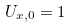<formula> <loc_0><loc_0><loc_500><loc_500>U _ { x , 0 } = 1</formula> 